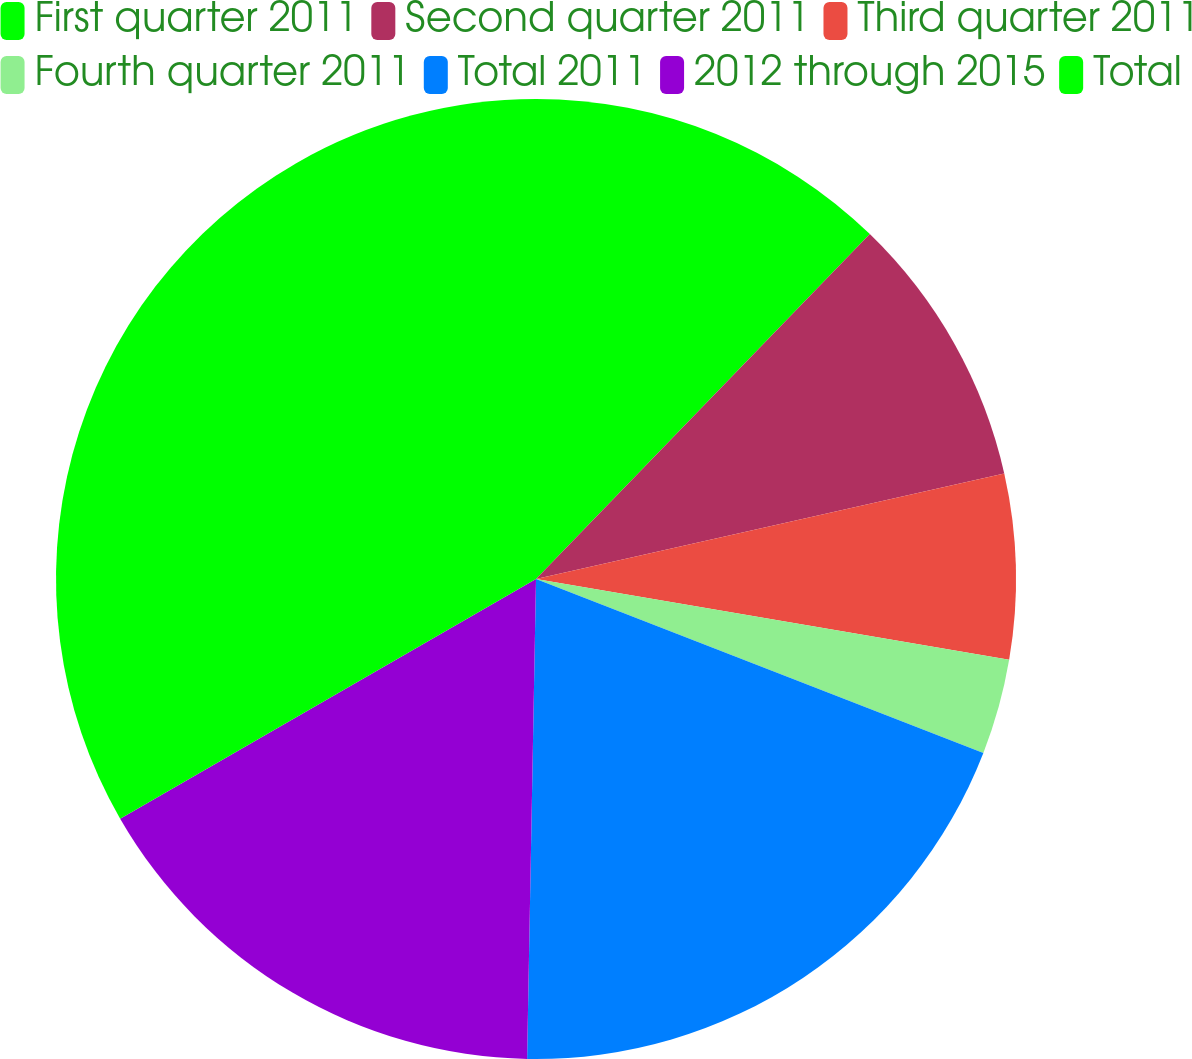Convert chart to OTSL. <chart><loc_0><loc_0><loc_500><loc_500><pie_chart><fcel>First quarter 2011<fcel>Second quarter 2011<fcel>Third quarter 2011<fcel>Fourth quarter 2011<fcel>Total 2011<fcel>2012 through 2015<fcel>Total<nl><fcel>12.24%<fcel>9.23%<fcel>6.22%<fcel>3.21%<fcel>19.39%<fcel>16.38%<fcel>33.32%<nl></chart> 